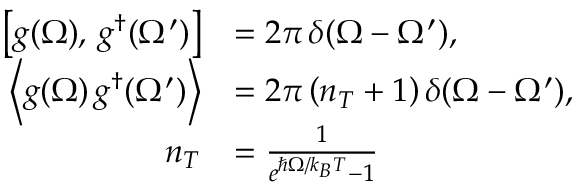<formula> <loc_0><loc_0><loc_500><loc_500>\begin{array} { r l } { \left [ g ( \Omega ) , \, g ^ { \dag } ( \Omega ^ { \prime } ) \right ] } & { = 2 \pi \, \delta ( \Omega - \Omega ^ { \prime } ) , } \\ { \left \langle g ( \Omega ) \, g ^ { \dag } ( \Omega ^ { \prime } ) \right \rangle } & { = 2 \pi \left ( n _ { T } + 1 \right ) \delta ( \Omega - \Omega ^ { \prime } ) , } \\ { n _ { T } } & { = \frac { 1 } { e ^ { \hslash \Omega / k _ { B } T } - 1 } } \end{array}</formula> 